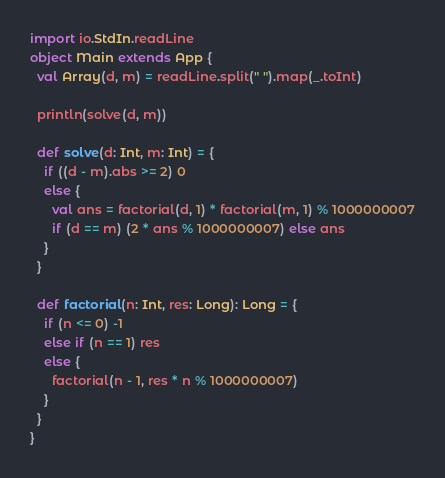Convert code to text. <code><loc_0><loc_0><loc_500><loc_500><_Scala_>import io.StdIn.readLine
object Main extends App {
  val Array(d, m) = readLine.split(" ").map(_.toInt)

  println(solve(d, m))

  def solve(d: Int, m: Int) = {
    if ((d - m).abs >= 2) 0
    else {
      val ans = factorial(d, 1) * factorial(m, 1) % 1000000007
      if (d == m) (2 * ans % 1000000007) else ans
    }
  }

  def factorial(n: Int, res: Long): Long = {
    if (n <= 0) -1
    else if (n == 1) res
    else {
      factorial(n - 1, res * n % 1000000007)
    }
  }
}
</code> 